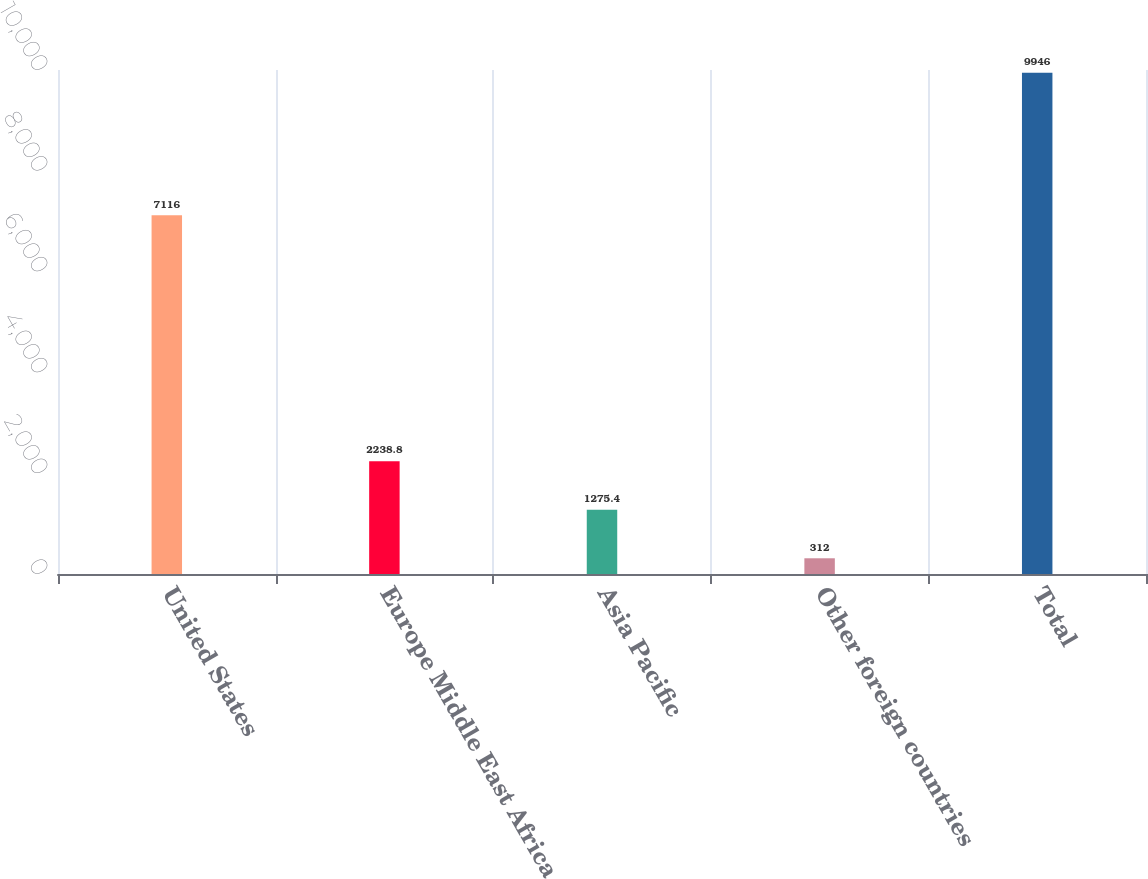<chart> <loc_0><loc_0><loc_500><loc_500><bar_chart><fcel>United States<fcel>Europe Middle East Africa<fcel>Asia Pacific<fcel>Other foreign countries<fcel>Total<nl><fcel>7116<fcel>2238.8<fcel>1275.4<fcel>312<fcel>9946<nl></chart> 